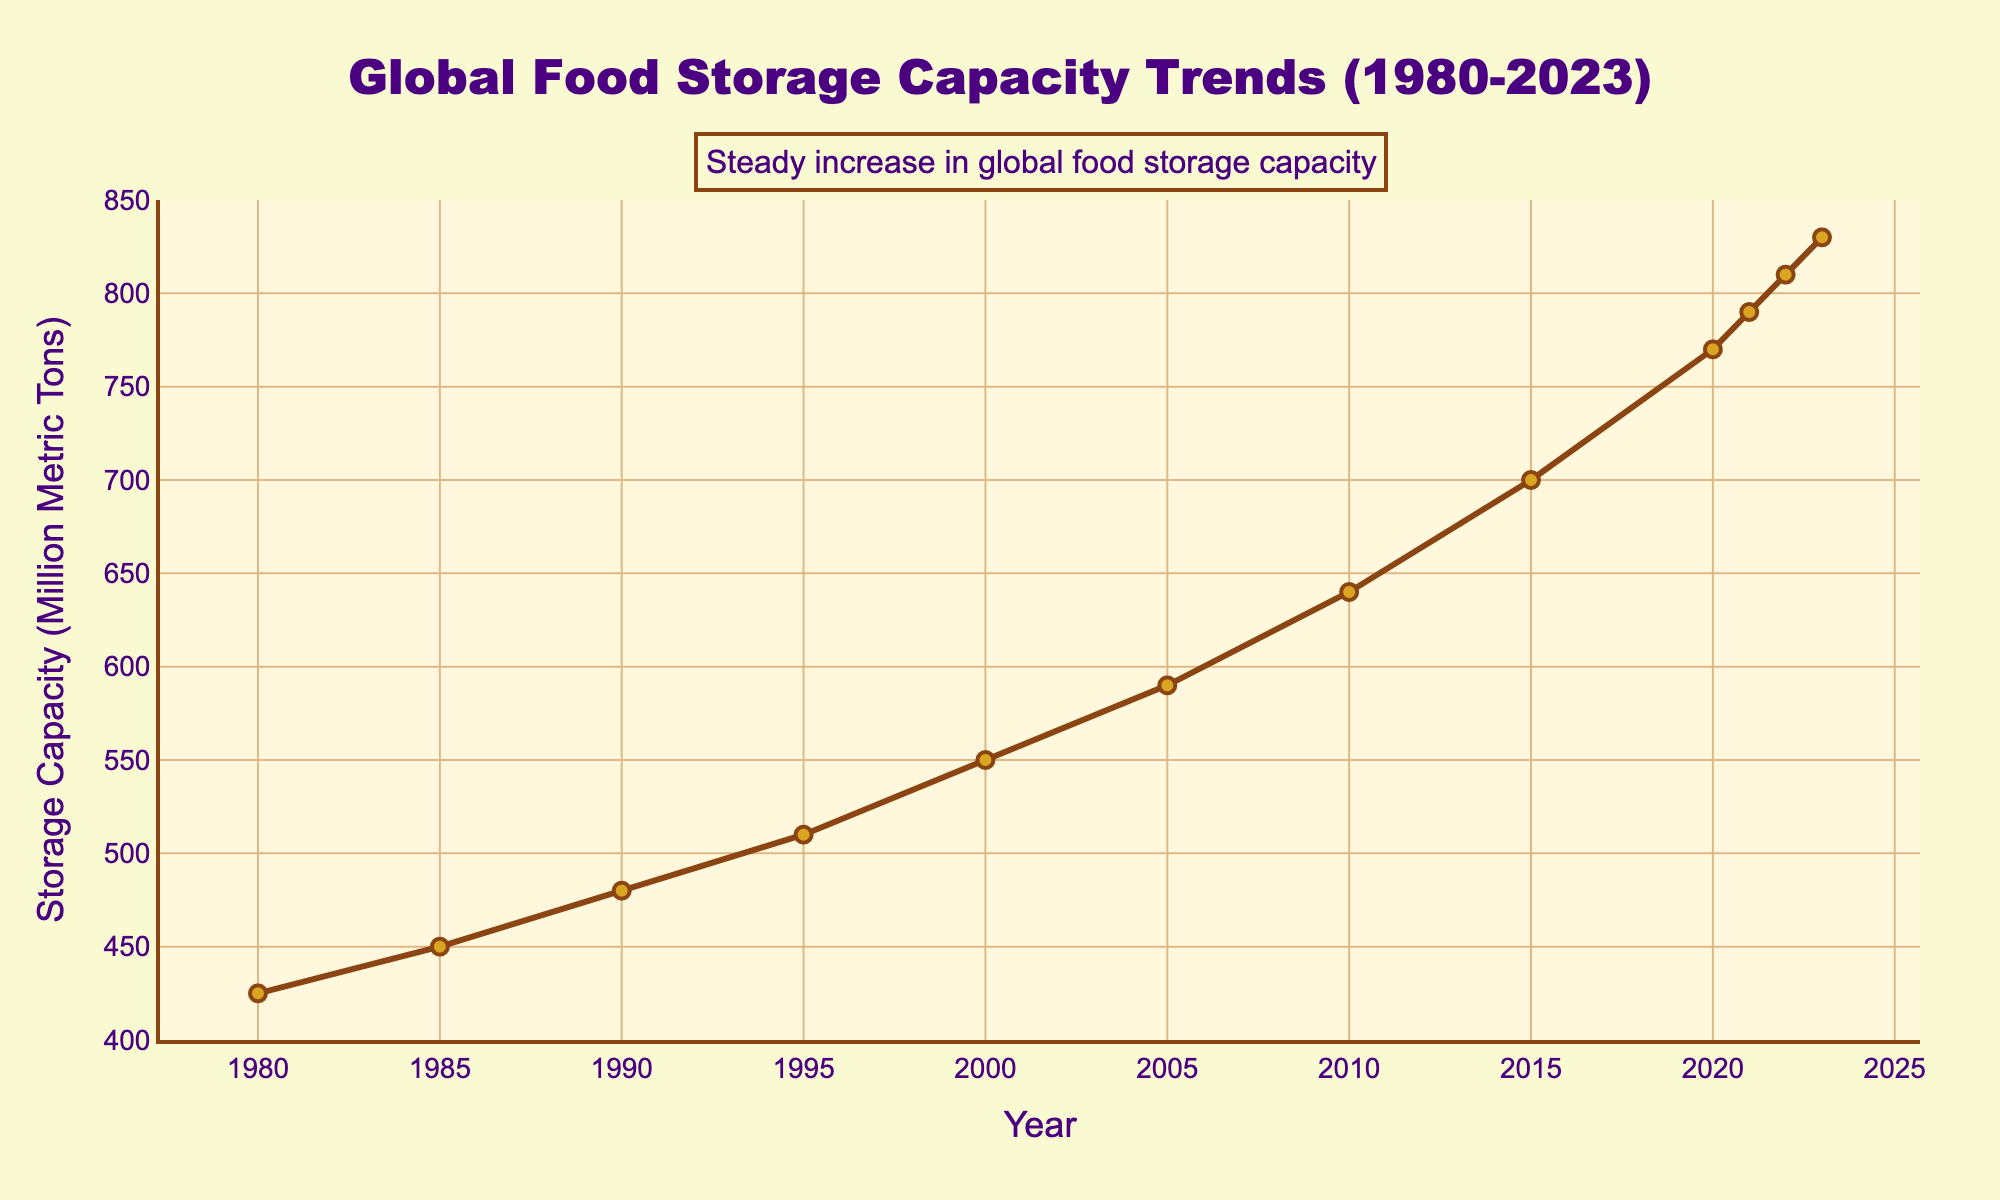what is the average global food storage capacity for the years 1980 and 2023? Add the storage capacities for 1980 (425 million metric tons) and 2023 (830 million metric tons), then divide by 2. (425 + 830) / 2 = 1275 / 2 = 637.5
Answer: 637.5 What is the overall trend observed in the global food storage capacity from 1980 to 2023? The global food storage capacity shows a steady increase from 425 million metric tons in 1980 to 830 million metric tons in 2023. The slope of the line is consistently upward with no periods of decrease.
Answer: Steady increase Which year saw the largest increase in global food storage capacity compared to the previous year? Calculate the differences between each consecutive year and identify the maximum. From 2015 to 2020, the capacity increased from 700 to 770 million metric tons, a change of 70 million metric tons, which is the largest increase.
Answer: 2015 to 2020 How much did the global food storage capacity increase from 1980 to 2000? Subtract the 1980 capacity (425 million metric tons) from the 2000 capacity (550 million metric tons). 550 - 425 = 125
Answer: 125 million metric tons What is the median value of global food storage capacity from 1980 to 2023? List the capacities in ascending order and find the middle value(s). Since there are 12 data points, the median is the average of the 6th and 7th values (590 and 640 million metric tons). (590 + 640) / 2 = 1230 / 2 = 615
Answer: 615 How does the increase in storage capacity from 2020 to 2023 compare to the increase from 2010 to 2015? From 2020 to 2023, the increase was (830 - 770) = 60 million metric tons. From 2010 to 2015, the increase was (700 - 640) = 60 million metric tons. Therefore, they are equal.
Answer: Equal Which period experienced the smallest increase in global food storage capacity? Identify the smallest difference between consecutive years. The smallest increase was from 2021 to 2022, with a rise of (810 - 790) = 20 million metric tons.
Answer: 2021 to 2022 Based on the trend from 1980 to 2023, what can you infer about future global food storage capacity? The consistent upward trend suggests that the global food storage capacity is likely to continue increasing in the future.
Answer: Likely to increase 